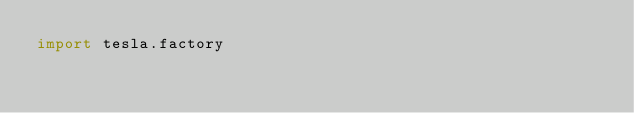Convert code to text. <code><loc_0><loc_0><loc_500><loc_500><_Python_>import tesla.factory</code> 